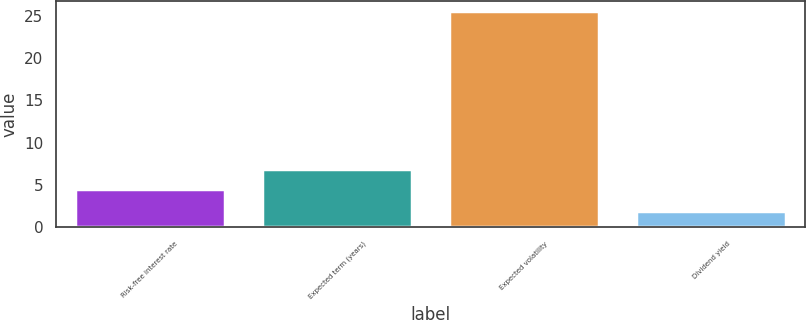Convert chart to OTSL. <chart><loc_0><loc_0><loc_500><loc_500><bar_chart><fcel>Risk-free interest rate<fcel>Expected term (years)<fcel>Expected volatility<fcel>Dividend yield<nl><fcel>4.57<fcel>6.93<fcel>25.5<fcel>1.89<nl></chart> 